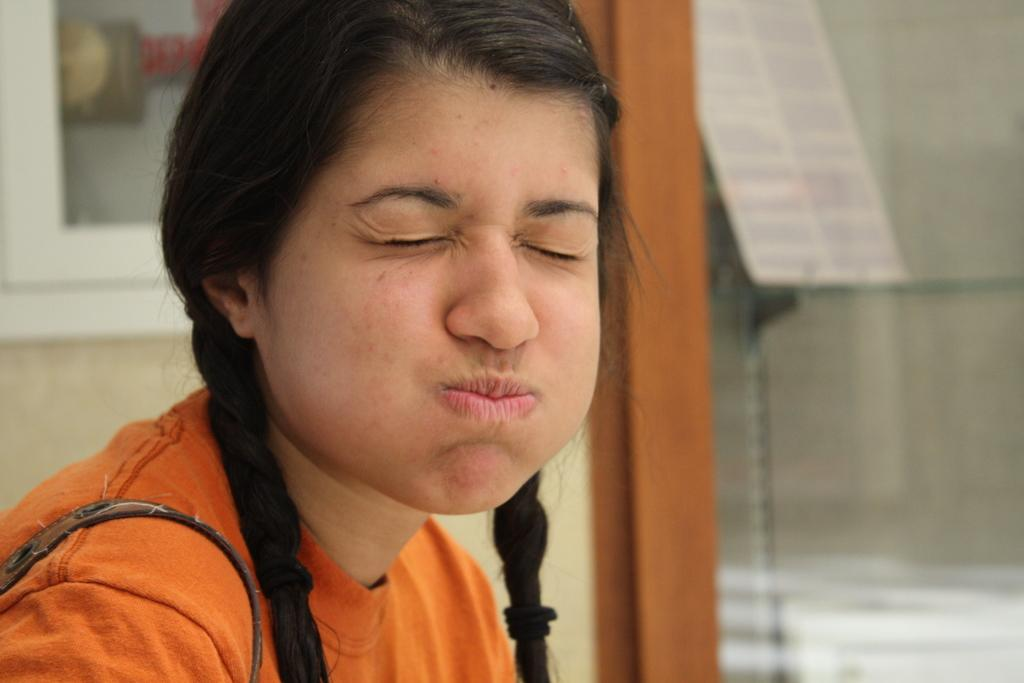What is the main subject of the image? There is a girl sitting in the image. Can you describe the background of the image? The background of the image is blurred. What word is the stranger trying to communicate to the girl in the image? There is no stranger present in the image, and therefore no communication can be observed. 